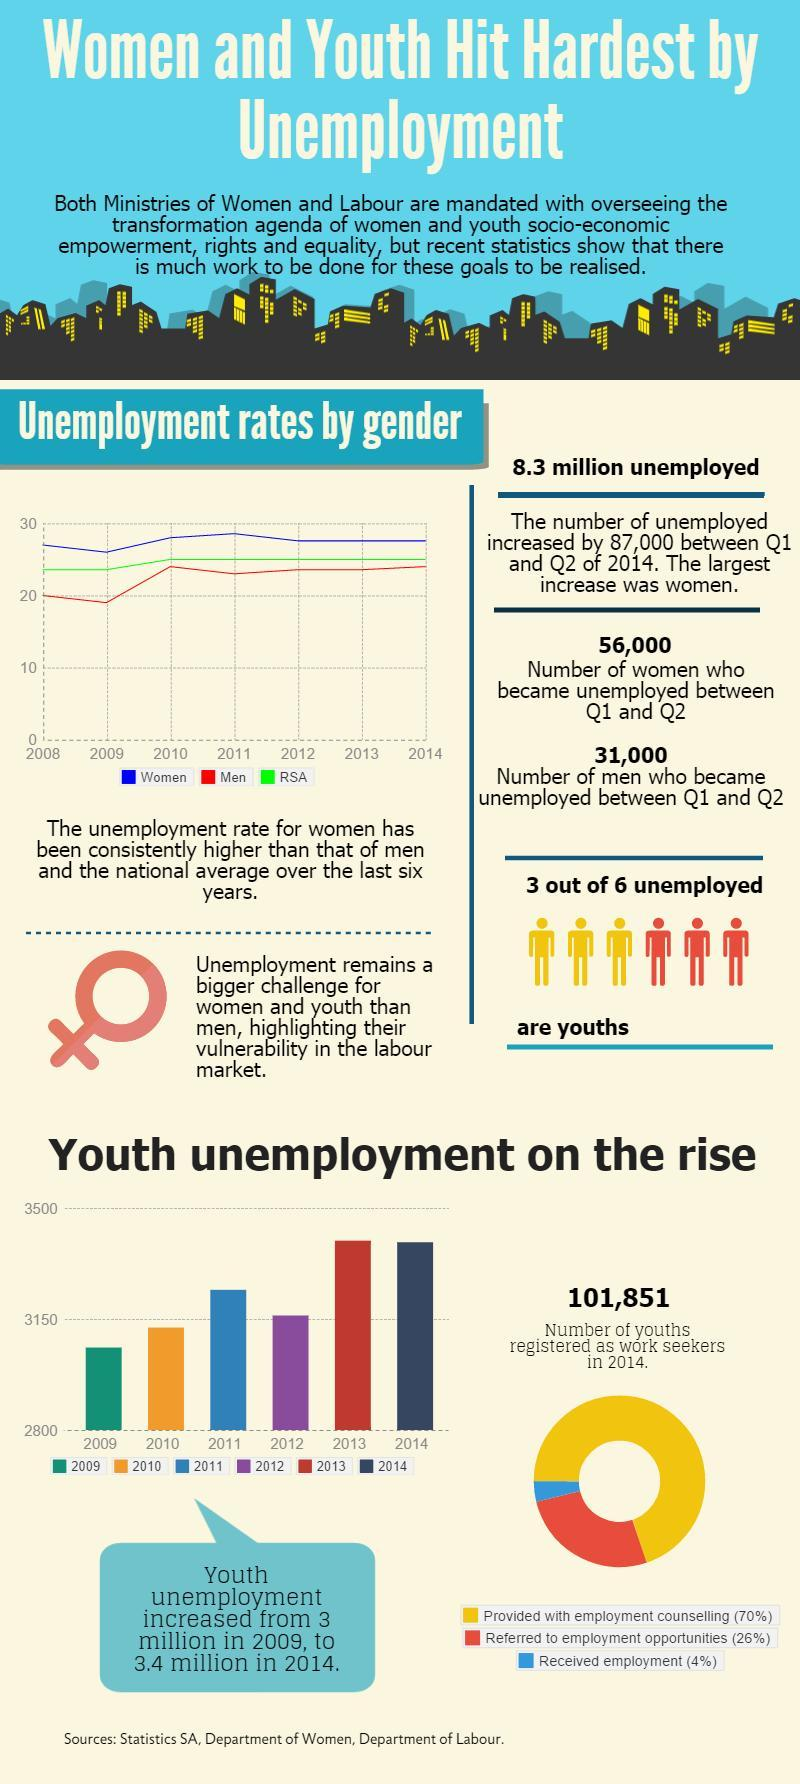In which years was unemployment below 3150?
Answer the question with a short phrase. 2009, 2010 